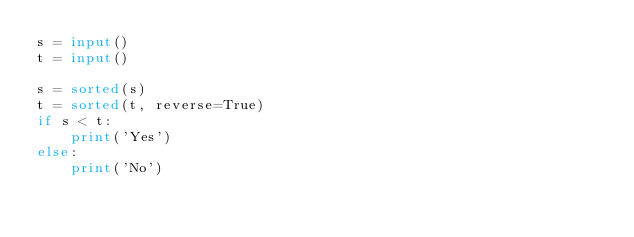<code> <loc_0><loc_0><loc_500><loc_500><_Python_>s = input()
t = input()

s = sorted(s)
t = sorted(t, reverse=True)
if s < t:
    print('Yes')
else:
    print('No')
</code> 